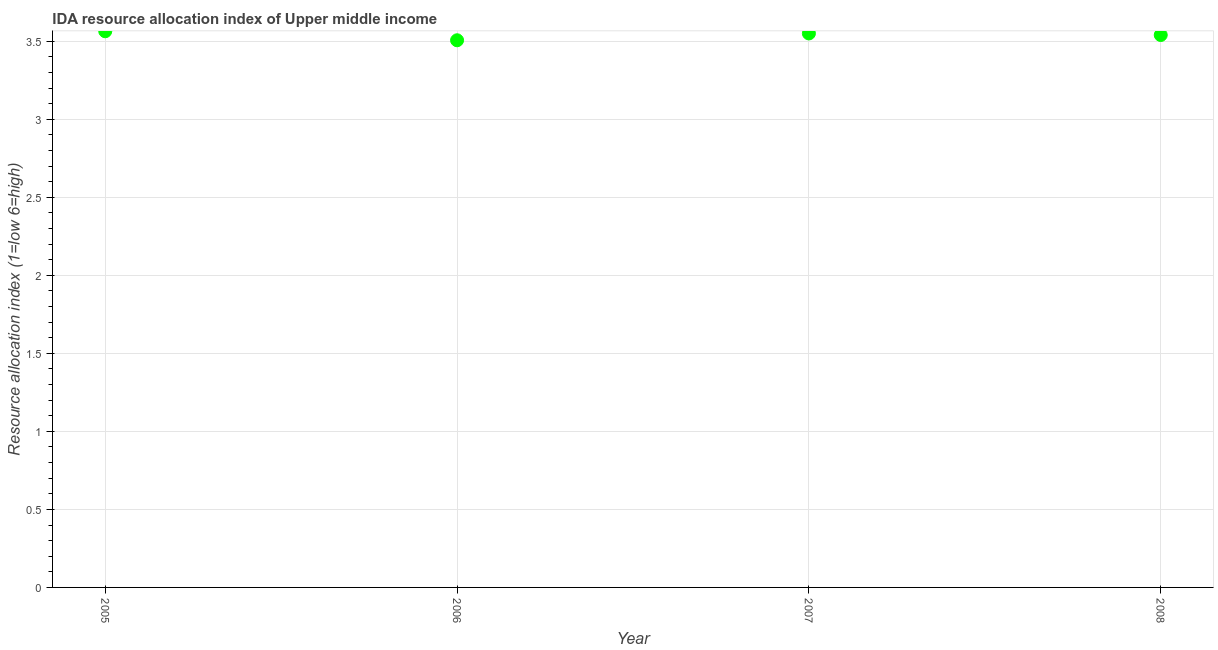What is the ida resource allocation index in 2006?
Provide a short and direct response. 3.51. Across all years, what is the maximum ida resource allocation index?
Your answer should be compact. 3.56. Across all years, what is the minimum ida resource allocation index?
Offer a terse response. 3.51. In which year was the ida resource allocation index minimum?
Your answer should be compact. 2006. What is the sum of the ida resource allocation index?
Keep it short and to the point. 14.16. What is the difference between the ida resource allocation index in 2006 and 2007?
Your response must be concise. -0.04. What is the average ida resource allocation index per year?
Offer a very short reply. 3.54. What is the median ida resource allocation index?
Make the answer very short. 3.54. In how many years, is the ida resource allocation index greater than 2.6 ?
Make the answer very short. 4. What is the ratio of the ida resource allocation index in 2005 to that in 2006?
Ensure brevity in your answer.  1.02. Is the ida resource allocation index in 2005 less than that in 2008?
Your answer should be compact. No. Is the difference between the ida resource allocation index in 2006 and 2007 greater than the difference between any two years?
Give a very brief answer. No. What is the difference between the highest and the second highest ida resource allocation index?
Keep it short and to the point. 0.01. Is the sum of the ida resource allocation index in 2006 and 2008 greater than the maximum ida resource allocation index across all years?
Give a very brief answer. Yes. What is the difference between the highest and the lowest ida resource allocation index?
Offer a terse response. 0.06. Are the values on the major ticks of Y-axis written in scientific E-notation?
Ensure brevity in your answer.  No. Does the graph contain any zero values?
Ensure brevity in your answer.  No. What is the title of the graph?
Provide a succinct answer. IDA resource allocation index of Upper middle income. What is the label or title of the X-axis?
Offer a very short reply. Year. What is the label or title of the Y-axis?
Ensure brevity in your answer.  Resource allocation index (1=low 6=high). What is the Resource allocation index (1=low 6=high) in 2005?
Make the answer very short. 3.56. What is the Resource allocation index (1=low 6=high) in 2006?
Offer a terse response. 3.51. What is the Resource allocation index (1=low 6=high) in 2007?
Ensure brevity in your answer.  3.55. What is the Resource allocation index (1=low 6=high) in 2008?
Offer a terse response. 3.54. What is the difference between the Resource allocation index (1=low 6=high) in 2005 and 2006?
Your answer should be very brief. 0.06. What is the difference between the Resource allocation index (1=low 6=high) in 2005 and 2007?
Keep it short and to the point. 0.01. What is the difference between the Resource allocation index (1=low 6=high) in 2005 and 2008?
Your answer should be compact. 0.02. What is the difference between the Resource allocation index (1=low 6=high) in 2006 and 2007?
Provide a short and direct response. -0.04. What is the difference between the Resource allocation index (1=low 6=high) in 2006 and 2008?
Ensure brevity in your answer.  -0.03. What is the difference between the Resource allocation index (1=low 6=high) in 2007 and 2008?
Offer a terse response. 0.01. What is the ratio of the Resource allocation index (1=low 6=high) in 2005 to that in 2006?
Provide a short and direct response. 1.02. What is the ratio of the Resource allocation index (1=low 6=high) in 2005 to that in 2007?
Offer a terse response. 1. What is the ratio of the Resource allocation index (1=low 6=high) in 2005 to that in 2008?
Offer a very short reply. 1.01. 